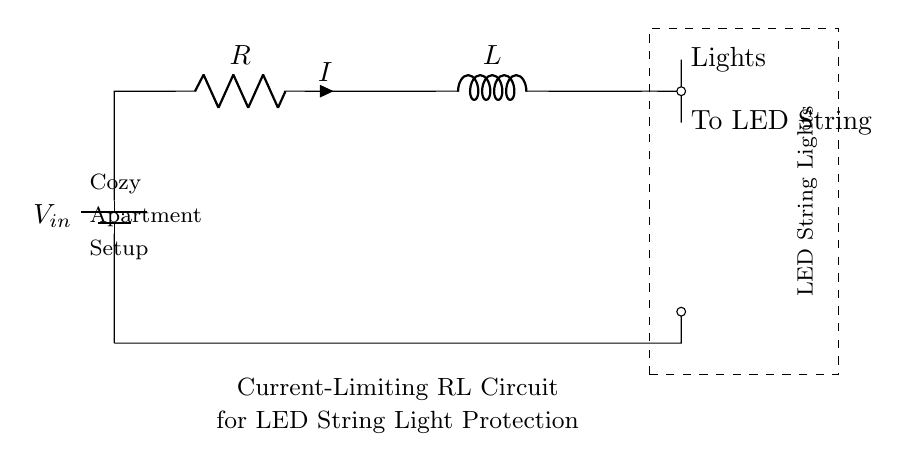What is the input voltage for this circuit? The input voltage is labeled as V sub in, which means it's the voltage supplied to the circuit. The specific value isn't provided in the diagram but is indicated in the labeling.
Answer: V in What component limits the current in this circuit? The component responsible for current limitation is the resistor, represented by R in the circuit diagram. Resistors limit the flow of electric current in a circuit.
Answer: Resistor What type of circuit is this? The circuit is classified as a Resistor-Inductor (RL) circuit, as it includes both a resistor and an inductor as its primary components.
Answer: RL circuit What is the role of the inductor in this circuit? The inductor is used to smooth the current and reduce fluctuations, making it beneficial for protecting sensitive components like LED lights. Its inductance offers resistance to changes in current.
Answer: Smooth current How are the LED lights connected to the circuit? The LED lights are connected in parallel to the output of the inductor, as indicated by the label "To LED String" leading from the inductor output. This allows them to operate at a steady voltage after the inductor has done its job.
Answer: In parallel What would happen if the resistor value is decreased? If the resistor value decreases, the current flow increases according to Ohm's Law, which could potentially lead to excess current that may damage the LED string lights. This makes the circuit less protective for the LEDs.
Answer: Increased current 